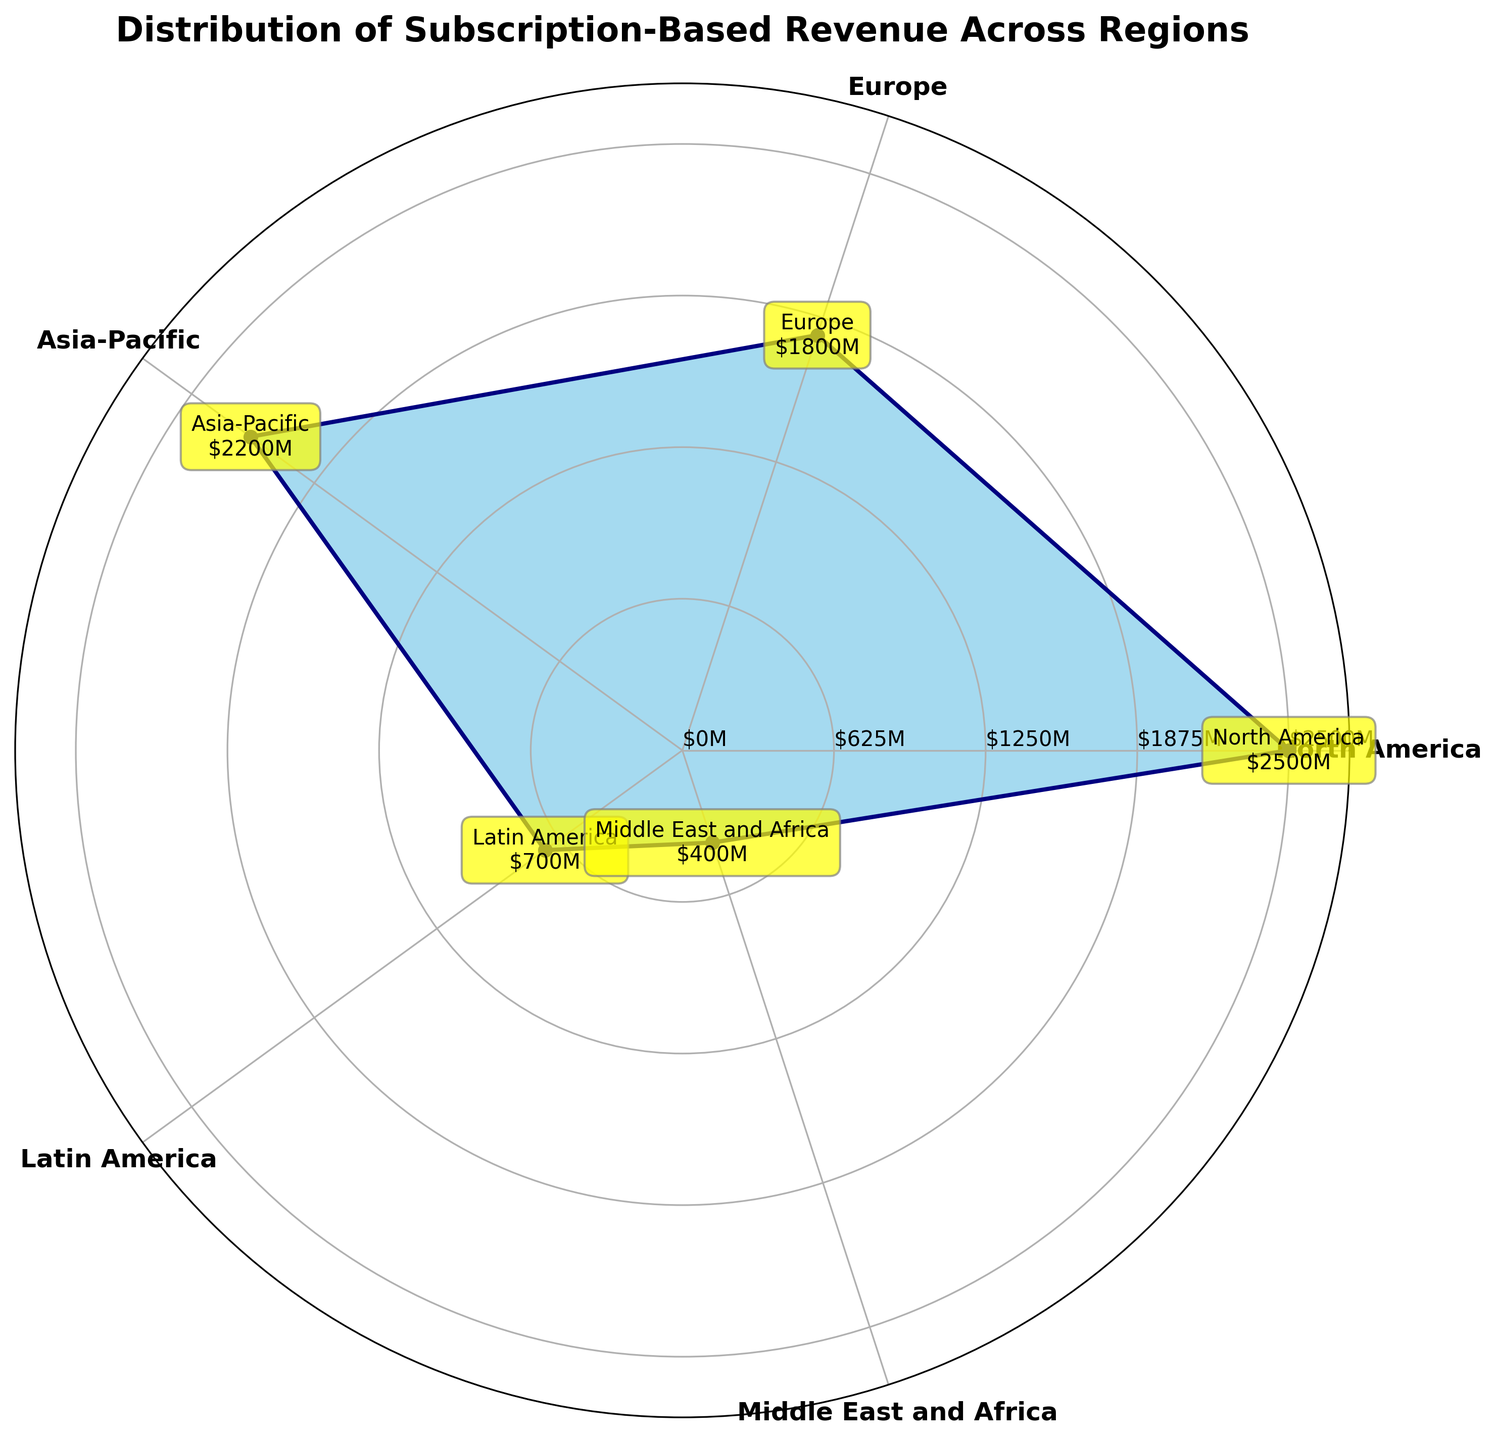what is the title of the chart? The title is clearly displayed at the top of the chart and reads "Distribution of Subscription-Based Revenue Across Regions."
Answer: Distribution of Subscription-Based Revenue Across Regions How many regions are shown in the chart? The chart has labeled points for each region around the polar plot. By counting these labels, we see there are five regions: North America, Europe, Asia-Pacific, Latin America, and Middle East and Africa.
Answer: Five What color is used to fill the polar area representing the subscription revenue? The area representing the subscription revenue is filled with a light sky blue color.
Answer: Sky blue Which region has the highest subscription revenue? By looking at the relative lengths of the areas in the polar chart which represent subscription revenue, North America has the largest area, indicating it has the highest revenue.
Answer: North America Which region shows the lowest subscription revenue? From the visual representation in the polar area chart with the shortest radius, Middle East and Africa has the smallest area, indicating the lowest revenue.
Answer: Middle East and Africa What is the difference in subscription revenue between North America and Europe? North America has a subscription revenue of $2500M and Europe has $1800M. Subtracting the latter from the former gives $2500M - $1800M = $700M.
Answer: $700M Calculate the average subscription revenue across all regions. Sum up the revenues: $2500M + $1800M + $2200M + $700M + $400M = $7600M. Divide by the number of regions, 7600M / 5 = $1520M.
Answer: $1520M How does Asia-Pacific's subscription revenue compare to Latin America's? Asia-Pacific has a subscription revenue of $2200M while Latin America shows $700M. Comparatively, Asia-Pacific's revenue is substantially higher.
Answer: Asia-Pacific is higher If the total global subscription revenue is $7.6 billion, what fraction of the total does North America contribute? North America has a revenue of $2500M. To find the fraction of the total $7600M, divide $2500M by $7600M, which gives 2500/7600 = approximately 0.329 or 32.9%.
Answer: 32.9% Can you identify a key region that stands out in terms of subscription revenue in this chart type? In a polar area chart, regions with larger areas stand out more visibly. North America's section is the largest, indicating it stands out due to its higher subscription revenue.
Answer: North America 